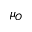Convert formula to latex. <formula><loc_0><loc_0><loc_500><loc_500>\mu _ { O }</formula> 